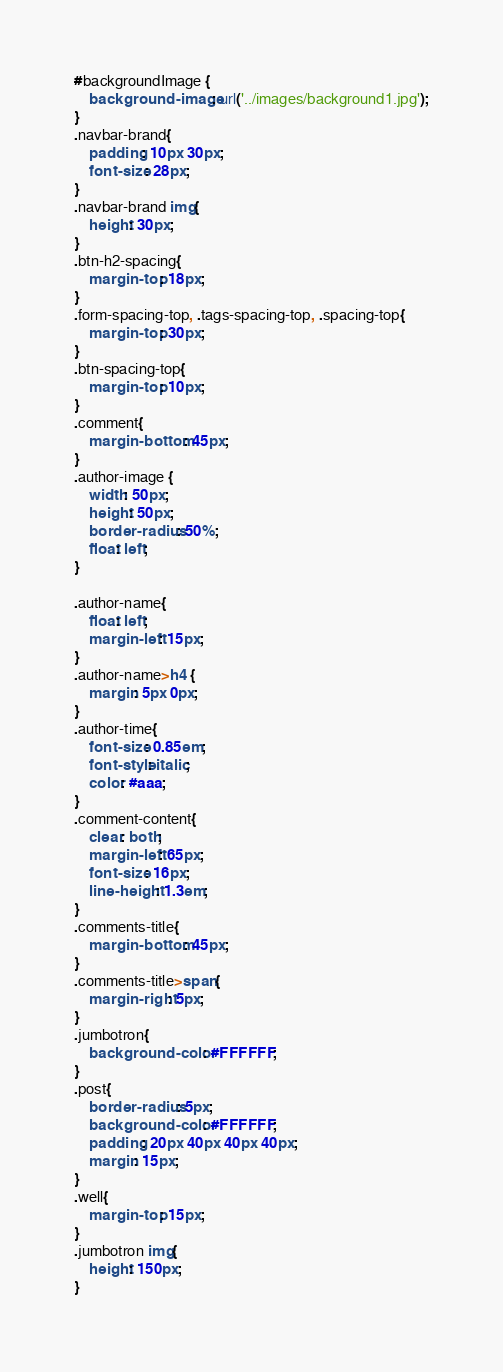Convert code to text. <code><loc_0><loc_0><loc_500><loc_500><_CSS_>#backgroundImage {
    background-image: url('../images/background1.jpg');
}
.navbar-brand{
    padding: 10px 30px;
    font-size: 28px;
}
.navbar-brand img{
    height: 30px;
}
.btn-h2-spacing{
    margin-top: 18px;
}
.form-spacing-top, .tags-spacing-top, .spacing-top{
    margin-top: 30px;
}
.btn-spacing-top{
    margin-top: 10px;
}
.comment{
    margin-bottom: 45px;
}
.author-image {
    width: 50px;
    height: 50px;
    border-radius: 50%;
    float: left;
}

.author-name{
    float: left;
    margin-left: 15px;
}
.author-name>h4 {
    margin: 5px 0px;
}
.author-time{
    font-size: 0.85em;
    font-style: italic;
    color: #aaa;
}
.comment-content{
    clear: both;
    margin-left: 65px;
    font-size: 16px;
    line-height: 1.3em;
}
.comments-title{
    margin-bottom: 45px;
}
.comments-title>span{
    margin-right: 5px;
}
.jumbotron{
    background-color: #FFFFFF;
}
.post{
    border-radius: 5px;
    background-color: #FFFFFF;
    padding: 20px 40px 40px 40px;
    margin: 15px;
}
.well{
    margin-top: 15px;
}
.jumbotron img{
    height: 150px;
}</code> 